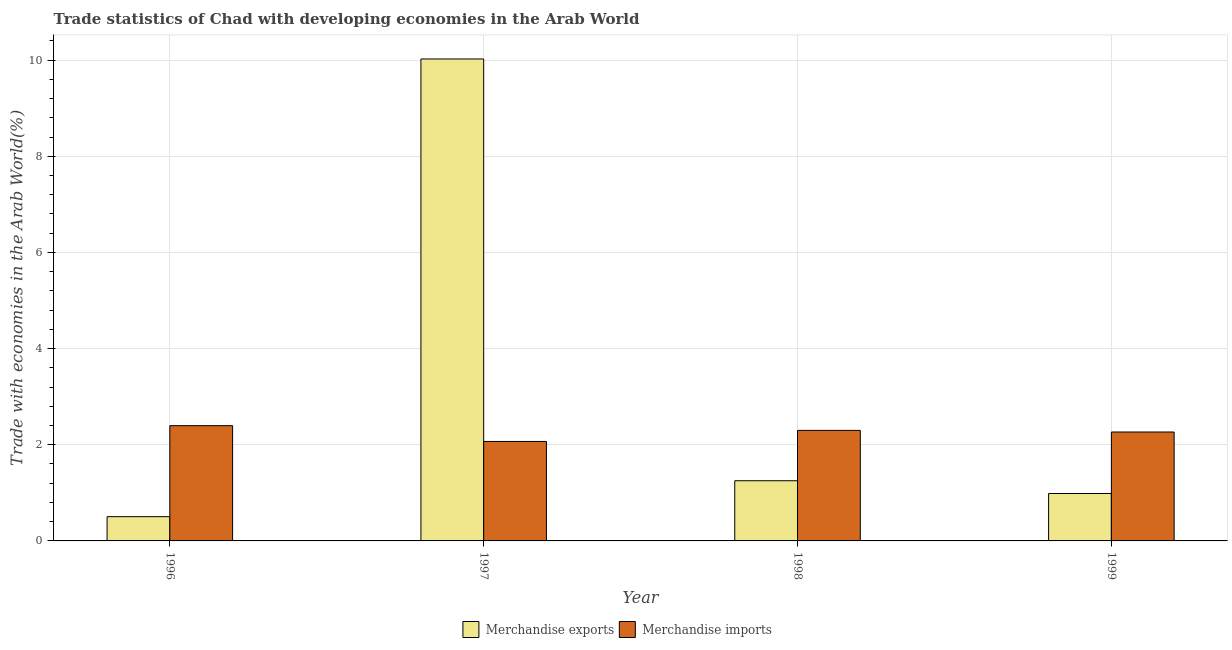How many different coloured bars are there?
Provide a succinct answer. 2. Are the number of bars per tick equal to the number of legend labels?
Make the answer very short. Yes. How many bars are there on the 2nd tick from the left?
Ensure brevity in your answer.  2. What is the label of the 2nd group of bars from the left?
Provide a succinct answer. 1997. In how many cases, is the number of bars for a given year not equal to the number of legend labels?
Offer a terse response. 0. What is the merchandise imports in 1997?
Keep it short and to the point. 2.07. Across all years, what is the maximum merchandise imports?
Your answer should be compact. 2.4. Across all years, what is the minimum merchandise exports?
Your answer should be very brief. 0.5. In which year was the merchandise exports maximum?
Your response must be concise. 1997. What is the total merchandise exports in the graph?
Ensure brevity in your answer.  12.77. What is the difference between the merchandise imports in 1998 and that in 1999?
Your response must be concise. 0.03. What is the difference between the merchandise exports in 1999 and the merchandise imports in 1998?
Ensure brevity in your answer.  -0.27. What is the average merchandise imports per year?
Offer a very short reply. 2.26. In how many years, is the merchandise imports greater than 3.2 %?
Your answer should be compact. 0. What is the ratio of the merchandise exports in 1997 to that in 1998?
Offer a very short reply. 8.01. Is the difference between the merchandise imports in 1998 and 1999 greater than the difference between the merchandise exports in 1998 and 1999?
Your answer should be compact. No. What is the difference between the highest and the second highest merchandise imports?
Give a very brief answer. 0.1. What is the difference between the highest and the lowest merchandise exports?
Make the answer very short. 9.52. Is the sum of the merchandise imports in 1996 and 1997 greater than the maximum merchandise exports across all years?
Keep it short and to the point. Yes. What does the 2nd bar from the right in 1998 represents?
Your answer should be compact. Merchandise exports. Are all the bars in the graph horizontal?
Provide a short and direct response. No. How many years are there in the graph?
Make the answer very short. 4. What is the difference between two consecutive major ticks on the Y-axis?
Provide a succinct answer. 2. Are the values on the major ticks of Y-axis written in scientific E-notation?
Give a very brief answer. No. What is the title of the graph?
Your answer should be compact. Trade statistics of Chad with developing economies in the Arab World. Does "Commercial service exports" appear as one of the legend labels in the graph?
Ensure brevity in your answer.  No. What is the label or title of the X-axis?
Make the answer very short. Year. What is the label or title of the Y-axis?
Offer a terse response. Trade with economies in the Arab World(%). What is the Trade with economies in the Arab World(%) in Merchandise exports in 1996?
Your response must be concise. 0.5. What is the Trade with economies in the Arab World(%) of Merchandise imports in 1996?
Your response must be concise. 2.4. What is the Trade with economies in the Arab World(%) in Merchandise exports in 1997?
Ensure brevity in your answer.  10.02. What is the Trade with economies in the Arab World(%) in Merchandise imports in 1997?
Provide a short and direct response. 2.07. What is the Trade with economies in the Arab World(%) in Merchandise exports in 1998?
Your response must be concise. 1.25. What is the Trade with economies in the Arab World(%) of Merchandise imports in 1998?
Make the answer very short. 2.3. What is the Trade with economies in the Arab World(%) in Merchandise exports in 1999?
Make the answer very short. 0.99. What is the Trade with economies in the Arab World(%) in Merchandise imports in 1999?
Make the answer very short. 2.27. Across all years, what is the maximum Trade with economies in the Arab World(%) in Merchandise exports?
Provide a succinct answer. 10.02. Across all years, what is the maximum Trade with economies in the Arab World(%) of Merchandise imports?
Make the answer very short. 2.4. Across all years, what is the minimum Trade with economies in the Arab World(%) in Merchandise exports?
Your response must be concise. 0.5. Across all years, what is the minimum Trade with economies in the Arab World(%) of Merchandise imports?
Your answer should be very brief. 2.07. What is the total Trade with economies in the Arab World(%) of Merchandise exports in the graph?
Your answer should be very brief. 12.77. What is the total Trade with economies in the Arab World(%) of Merchandise imports in the graph?
Keep it short and to the point. 9.03. What is the difference between the Trade with economies in the Arab World(%) of Merchandise exports in 1996 and that in 1997?
Provide a succinct answer. -9.52. What is the difference between the Trade with economies in the Arab World(%) of Merchandise imports in 1996 and that in 1997?
Provide a short and direct response. 0.33. What is the difference between the Trade with economies in the Arab World(%) in Merchandise exports in 1996 and that in 1998?
Your answer should be very brief. -0.75. What is the difference between the Trade with economies in the Arab World(%) of Merchandise imports in 1996 and that in 1998?
Offer a terse response. 0.1. What is the difference between the Trade with economies in the Arab World(%) of Merchandise exports in 1996 and that in 1999?
Give a very brief answer. -0.48. What is the difference between the Trade with economies in the Arab World(%) of Merchandise imports in 1996 and that in 1999?
Your answer should be very brief. 0.13. What is the difference between the Trade with economies in the Arab World(%) of Merchandise exports in 1997 and that in 1998?
Your answer should be compact. 8.77. What is the difference between the Trade with economies in the Arab World(%) in Merchandise imports in 1997 and that in 1998?
Make the answer very short. -0.23. What is the difference between the Trade with economies in the Arab World(%) of Merchandise exports in 1997 and that in 1999?
Make the answer very short. 9.04. What is the difference between the Trade with economies in the Arab World(%) in Merchandise imports in 1997 and that in 1999?
Provide a short and direct response. -0.2. What is the difference between the Trade with economies in the Arab World(%) in Merchandise exports in 1998 and that in 1999?
Provide a short and direct response. 0.27. What is the difference between the Trade with economies in the Arab World(%) in Merchandise imports in 1998 and that in 1999?
Provide a short and direct response. 0.03. What is the difference between the Trade with economies in the Arab World(%) of Merchandise exports in 1996 and the Trade with economies in the Arab World(%) of Merchandise imports in 1997?
Your answer should be very brief. -1.56. What is the difference between the Trade with economies in the Arab World(%) of Merchandise exports in 1996 and the Trade with economies in the Arab World(%) of Merchandise imports in 1998?
Keep it short and to the point. -1.79. What is the difference between the Trade with economies in the Arab World(%) of Merchandise exports in 1996 and the Trade with economies in the Arab World(%) of Merchandise imports in 1999?
Offer a very short reply. -1.76. What is the difference between the Trade with economies in the Arab World(%) in Merchandise exports in 1997 and the Trade with economies in the Arab World(%) in Merchandise imports in 1998?
Make the answer very short. 7.73. What is the difference between the Trade with economies in the Arab World(%) of Merchandise exports in 1997 and the Trade with economies in the Arab World(%) of Merchandise imports in 1999?
Give a very brief answer. 7.76. What is the difference between the Trade with economies in the Arab World(%) in Merchandise exports in 1998 and the Trade with economies in the Arab World(%) in Merchandise imports in 1999?
Provide a short and direct response. -1.01. What is the average Trade with economies in the Arab World(%) of Merchandise exports per year?
Offer a terse response. 3.19. What is the average Trade with economies in the Arab World(%) of Merchandise imports per year?
Your answer should be compact. 2.26. In the year 1996, what is the difference between the Trade with economies in the Arab World(%) of Merchandise exports and Trade with economies in the Arab World(%) of Merchandise imports?
Your answer should be very brief. -1.89. In the year 1997, what is the difference between the Trade with economies in the Arab World(%) of Merchandise exports and Trade with economies in the Arab World(%) of Merchandise imports?
Your answer should be compact. 7.96. In the year 1998, what is the difference between the Trade with economies in the Arab World(%) in Merchandise exports and Trade with economies in the Arab World(%) in Merchandise imports?
Provide a short and direct response. -1.05. In the year 1999, what is the difference between the Trade with economies in the Arab World(%) in Merchandise exports and Trade with economies in the Arab World(%) in Merchandise imports?
Your answer should be very brief. -1.28. What is the ratio of the Trade with economies in the Arab World(%) in Merchandise exports in 1996 to that in 1997?
Keep it short and to the point. 0.05. What is the ratio of the Trade with economies in the Arab World(%) of Merchandise imports in 1996 to that in 1997?
Keep it short and to the point. 1.16. What is the ratio of the Trade with economies in the Arab World(%) of Merchandise exports in 1996 to that in 1998?
Give a very brief answer. 0.4. What is the ratio of the Trade with economies in the Arab World(%) of Merchandise imports in 1996 to that in 1998?
Your answer should be very brief. 1.04. What is the ratio of the Trade with economies in the Arab World(%) in Merchandise exports in 1996 to that in 1999?
Make the answer very short. 0.51. What is the ratio of the Trade with economies in the Arab World(%) in Merchandise imports in 1996 to that in 1999?
Provide a succinct answer. 1.06. What is the ratio of the Trade with economies in the Arab World(%) of Merchandise exports in 1997 to that in 1998?
Your response must be concise. 8.01. What is the ratio of the Trade with economies in the Arab World(%) of Merchandise exports in 1997 to that in 1999?
Ensure brevity in your answer.  10.16. What is the ratio of the Trade with economies in the Arab World(%) of Merchandise imports in 1997 to that in 1999?
Make the answer very short. 0.91. What is the ratio of the Trade with economies in the Arab World(%) of Merchandise exports in 1998 to that in 1999?
Provide a short and direct response. 1.27. What is the ratio of the Trade with economies in the Arab World(%) in Merchandise imports in 1998 to that in 1999?
Your response must be concise. 1.01. What is the difference between the highest and the second highest Trade with economies in the Arab World(%) in Merchandise exports?
Give a very brief answer. 8.77. What is the difference between the highest and the second highest Trade with economies in the Arab World(%) of Merchandise imports?
Your answer should be compact. 0.1. What is the difference between the highest and the lowest Trade with economies in the Arab World(%) of Merchandise exports?
Offer a very short reply. 9.52. What is the difference between the highest and the lowest Trade with economies in the Arab World(%) in Merchandise imports?
Your answer should be very brief. 0.33. 